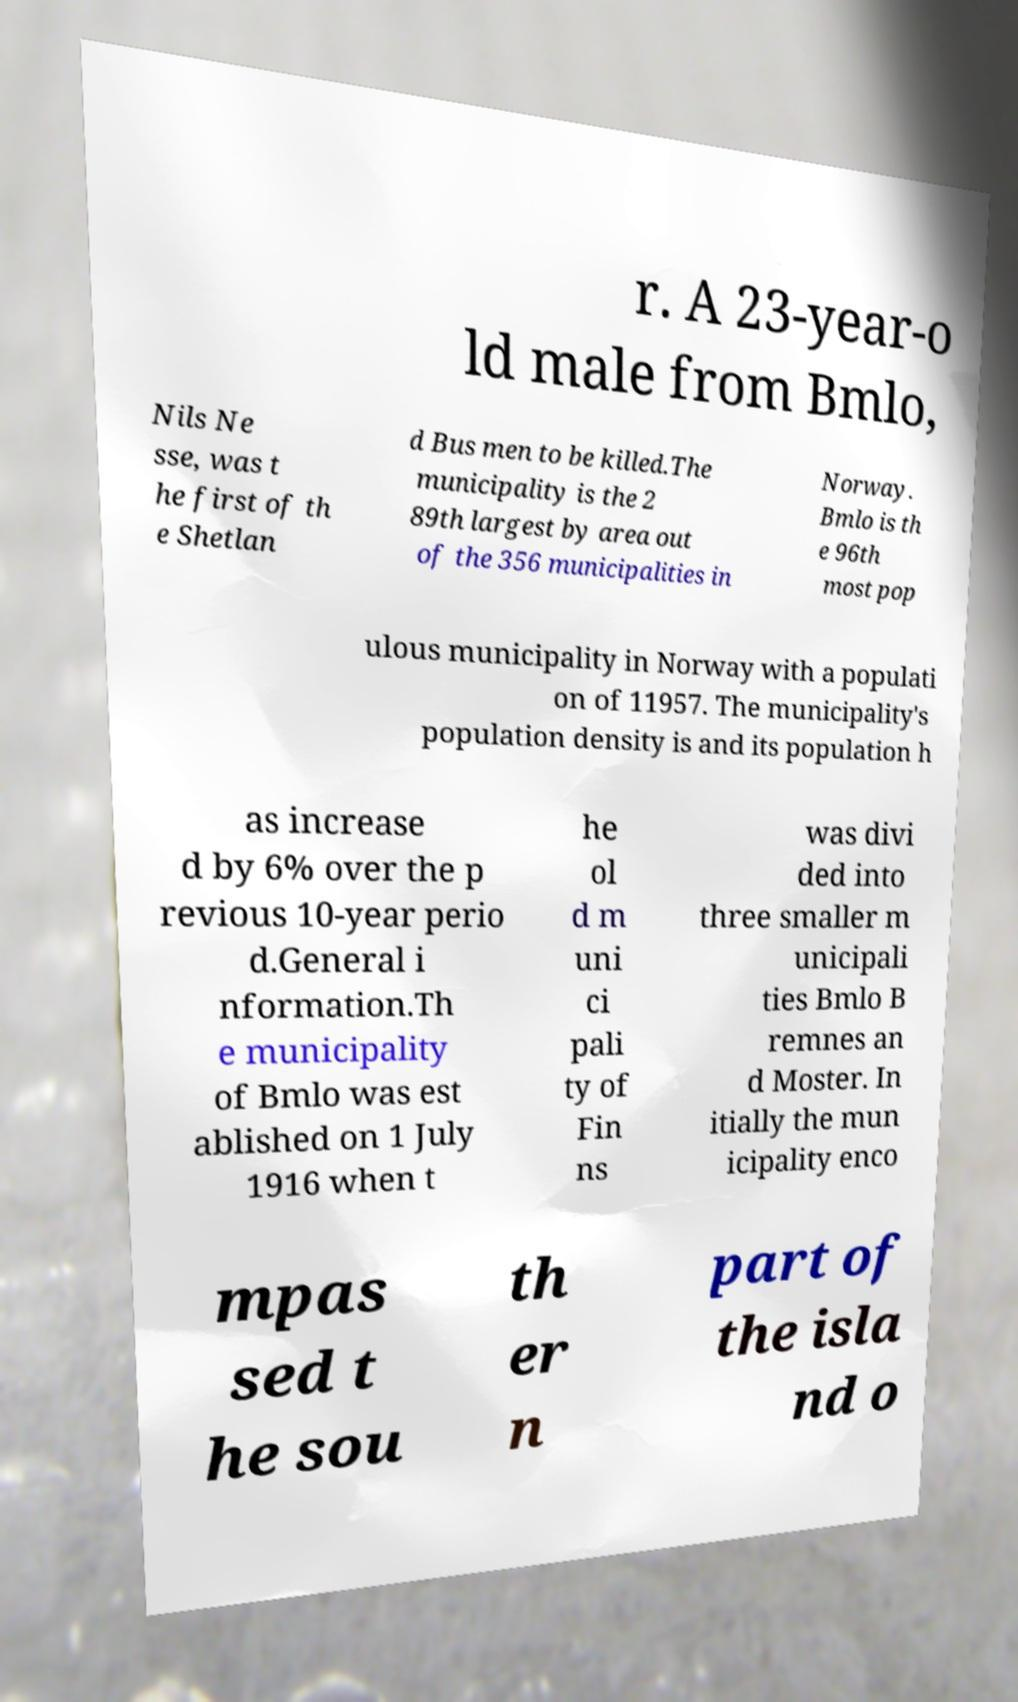What messages or text are displayed in this image? I need them in a readable, typed format. r. A 23-year-o ld male from Bmlo, Nils Ne sse, was t he first of th e Shetlan d Bus men to be killed.The municipality is the 2 89th largest by area out of the 356 municipalities in Norway. Bmlo is th e 96th most pop ulous municipality in Norway with a populati on of 11957. The municipality's population density is and its population h as increase d by 6% over the p revious 10-year perio d.General i nformation.Th e municipality of Bmlo was est ablished on 1 July 1916 when t he ol d m uni ci pali ty of Fin ns was divi ded into three smaller m unicipali ties Bmlo B remnes an d Moster. In itially the mun icipality enco mpas sed t he sou th er n part of the isla nd o 